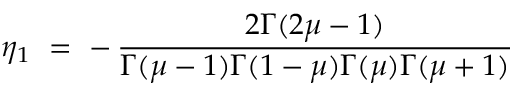Convert formula to latex. <formula><loc_0><loc_0><loc_500><loc_500>\eta _ { 1 } = - \, \frac { 2 \Gamma ( 2 \mu - 1 ) } { \Gamma ( \mu - 1 ) \Gamma ( 1 - \mu ) \Gamma ( \mu ) \Gamma ( \mu + 1 ) }</formula> 